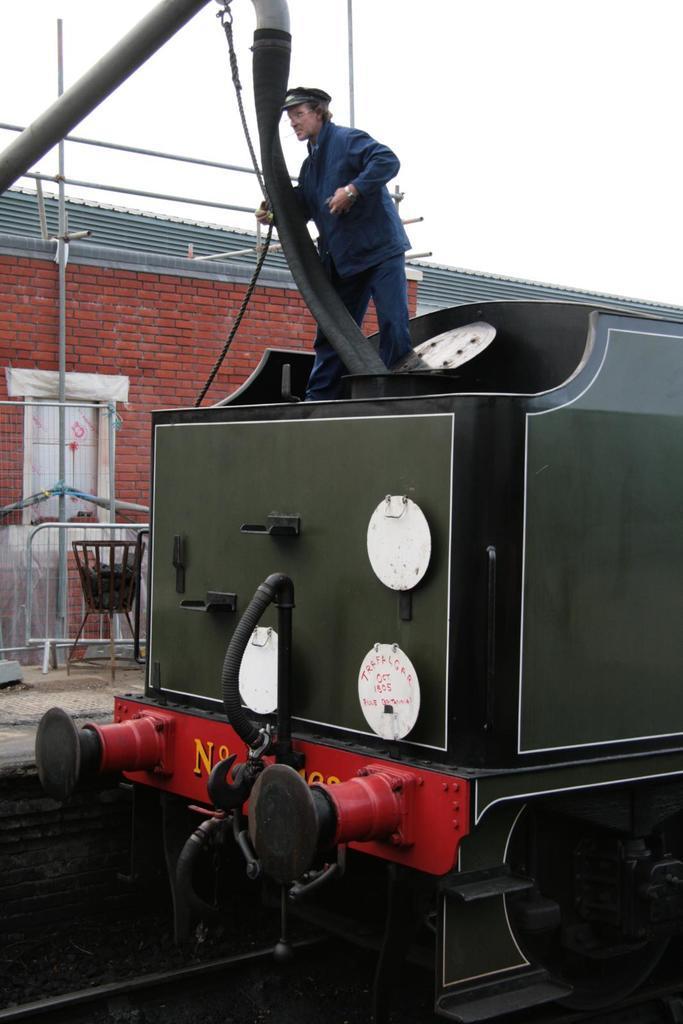Please provide a concise description of this image. In this image I can see a train which is green, black, white and red in color is on the railway track. I can see a person wearing blue colored dress is on the train. In the background I can see a building which is made up of bricks, a pipe and the sky. 